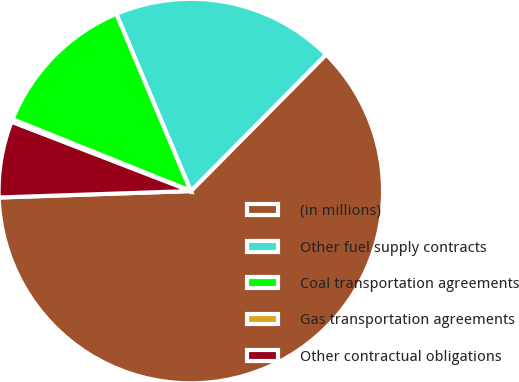Convert chart. <chart><loc_0><loc_0><loc_500><loc_500><pie_chart><fcel>(in millions)<fcel>Other fuel supply contracts<fcel>Coal transportation agreements<fcel>Gas transportation agreements<fcel>Other contractual obligations<nl><fcel>62.04%<fcel>18.76%<fcel>12.58%<fcel>0.22%<fcel>6.4%<nl></chart> 